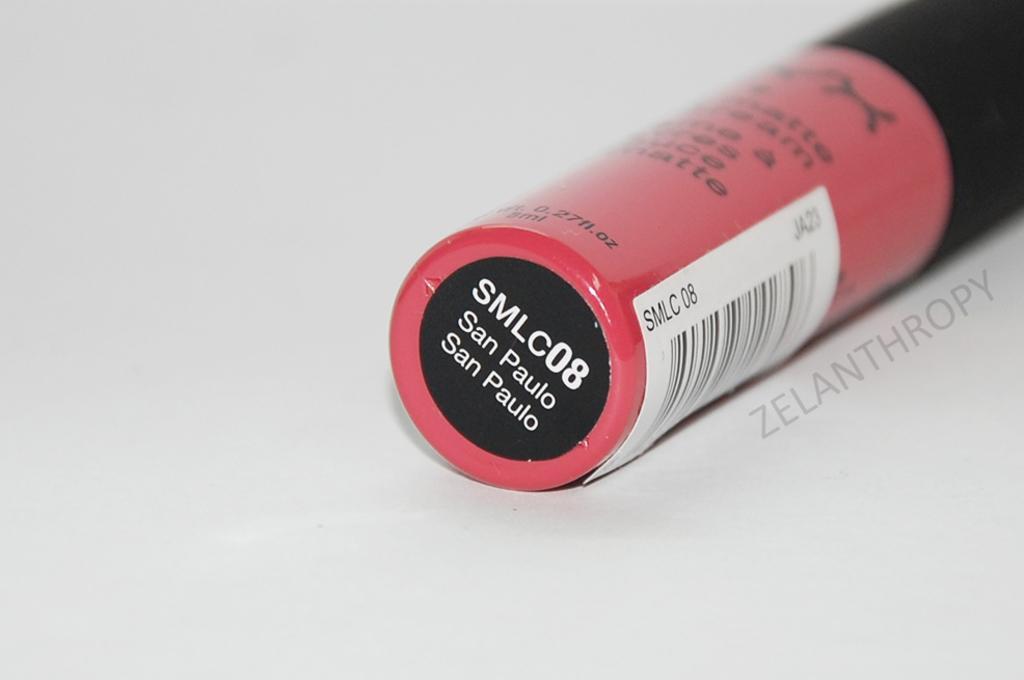How would you summarize this image in a sentence or two? In this image there is a gray colored surface and on the right side of the image there is an object with a text on it. 